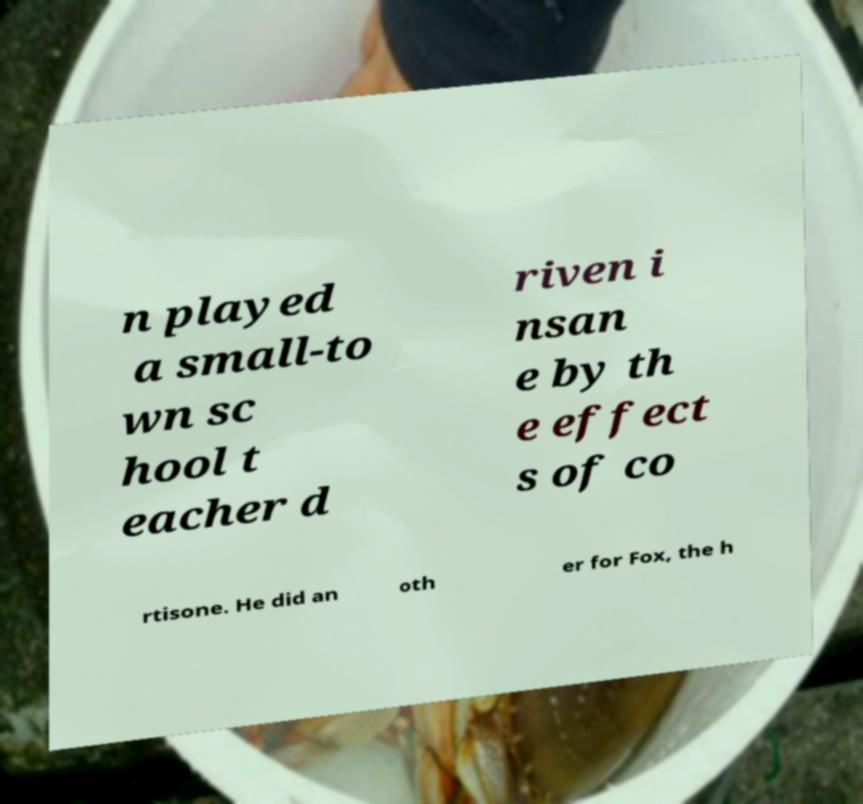Please identify and transcribe the text found in this image. n played a small-to wn sc hool t eacher d riven i nsan e by th e effect s of co rtisone. He did an oth er for Fox, the h 